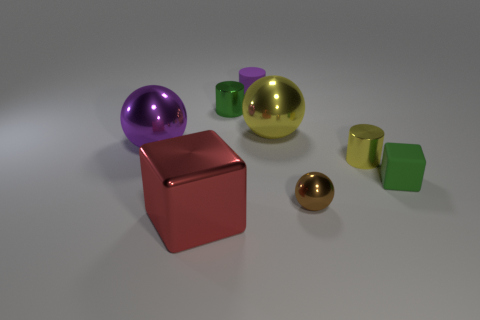The tiny matte cube is what color?
Your answer should be compact. Green. What color is the metallic cylinder that is the same size as the green metallic object?
Make the answer very short. Yellow. Is there a matte cylinder of the same color as the large metallic block?
Offer a very short reply. No. Is the shape of the green thing that is to the right of the purple rubber cylinder the same as the purple object that is behind the large purple thing?
Give a very brief answer. No. What is the size of the cylinder that is the same color as the rubber cube?
Offer a very short reply. Small. What number of other things are the same size as the yellow cylinder?
Keep it short and to the point. 4. There is a matte block; is it the same color as the large thing on the right side of the red metallic object?
Your response must be concise. No. Is the number of rubber objects that are to the right of the small brown thing less than the number of purple rubber cylinders that are in front of the large yellow metal sphere?
Provide a short and direct response. No. What color is the big shiny object that is to the right of the big purple shiny thing and behind the red object?
Provide a succinct answer. Yellow. Do the green metal cylinder and the block that is right of the red object have the same size?
Your answer should be very brief. Yes. 